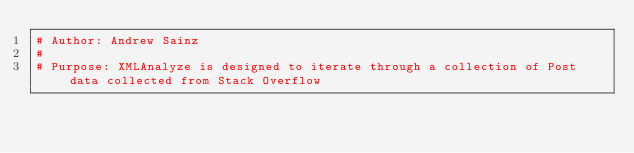Convert code to text. <code><loc_0><loc_0><loc_500><loc_500><_Python_># Author: Andrew Sainz
# 
# Purpose: XMLAnalyze is designed to iterate through a collection of Post data collected from Stack Overflow</code> 